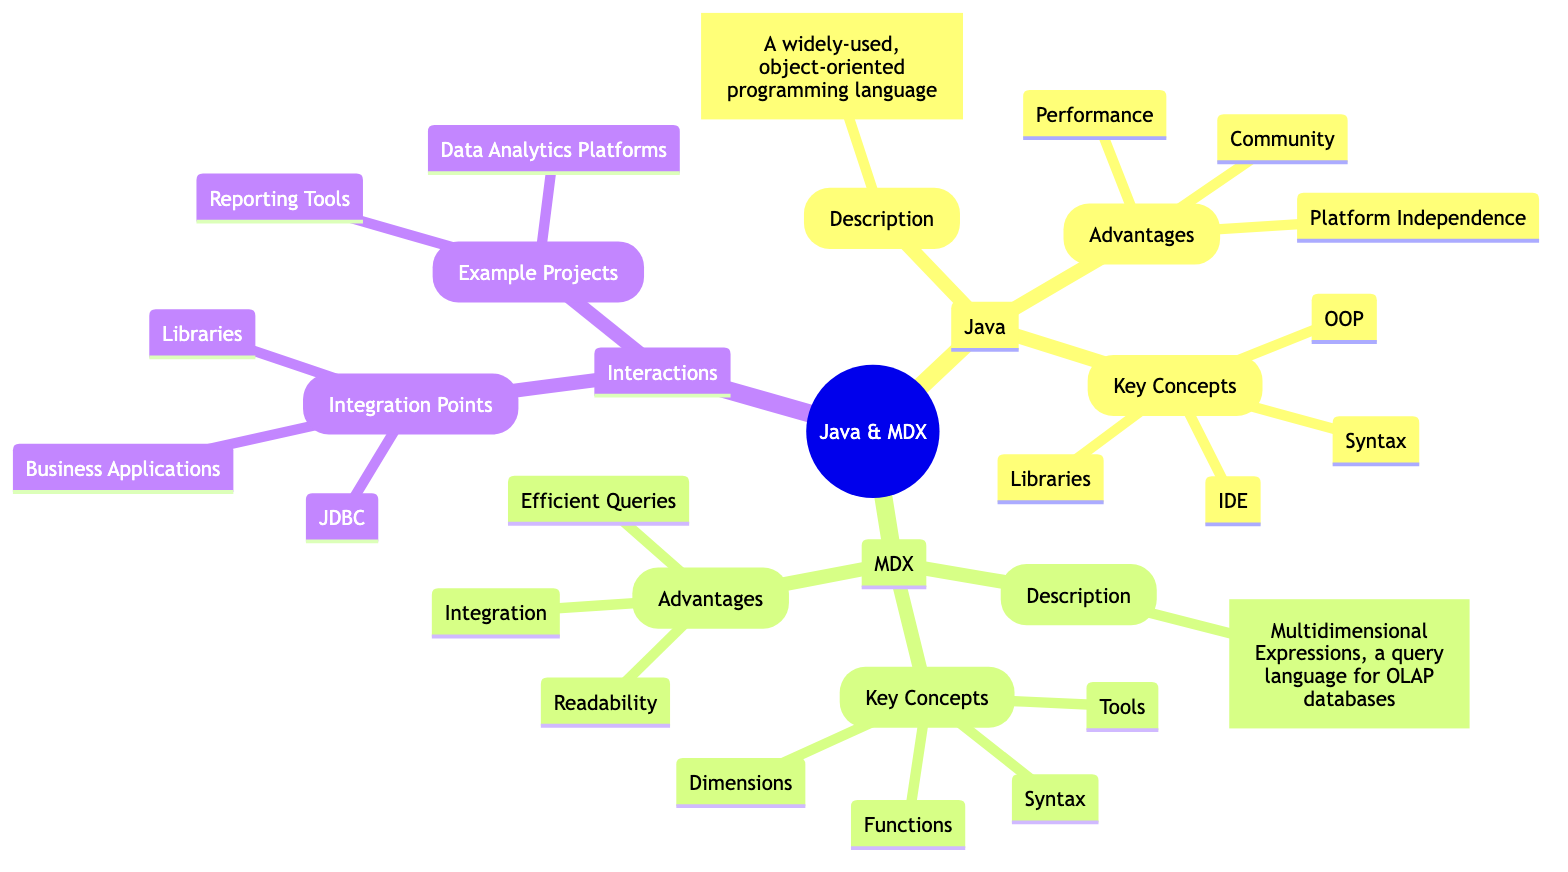What programming paradigm does Java follow? Java is described as an object-oriented programming language, emphasizing concepts such as inheritance, encapsulation, and polymorphism. This defines its programming paradigm.
Answer: Object-oriented programming What is a key advantage of Java? The diagram lists advantages of Java, among which "Platform Independence" is highlighted, indicating that Java can run on various platforms without modification.
Answer: Platform Independence How many key concepts are listed under MDX? By reviewing the "Key Concepts" section under MDX, you can count the concepts listed: Syntax, Dimensions, Functions, and Tools, totaling four unique concepts.
Answer: Four Which library is mentioned for executing MDX queries in Java? The diagram indicates that "olap4j" is a library used in Java to execute MDX queries, representing a specific integration point between the two technologies.
Answer: olap4j What do "Data Analytics Platforms" and "Reporting Tools" represent? These two items are located under "Example Projects" in the "Interactions" section and showcase practical applications where Java and MDX intersect, specifically in data analytics and reporting.
Answer: Example projects What is the main purpose of MDX? The description of MDX clearly states that it is a query language for OLAP databases, indicating its primary function in handling complex data retrieval tasks.
Answer: Query language for OLAP databases How can Java interact with databases that support MDX? The diagram mentions that Java can interact with such databases through JDBC, which stands for Java Database Connectivity, a standard API for connecting Java applications to databases.
Answer: JDBC What is a distinct feature of MDX mentioned in its advantages? "Efficient Queries" is stated in the advantages of MDX, indicating that MDX is particularly optimized for performing complex queries on multi-dimensional data.
Answer: Efficient Queries Which sections are compared in this mind map? The mind map compares the "Java" section and the "MDX" section, focusing on their distinct features, advantages, and their interactions in the context of data processing and analytics.
Answer: Java and MDX 